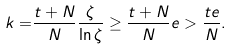<formula> <loc_0><loc_0><loc_500><loc_500>k = & \frac { t + N } { N } \frac { \zeta } { \ln \zeta } \geq \frac { t + N } { N } e > \frac { t e } { N } .</formula> 